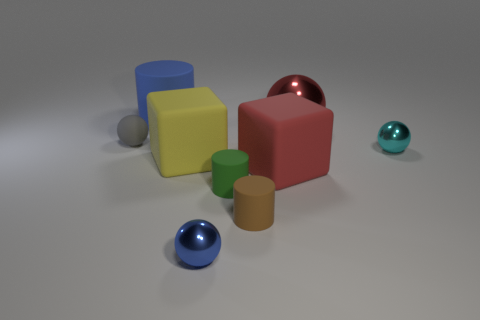What is the shape of the big red thing that is made of the same material as the small blue thing?
Give a very brief answer. Sphere. There is a rubber cylinder that is behind the small ball to the right of the red matte block; what size is it?
Ensure brevity in your answer.  Large. How many tiny things are either gray rubber cylinders or gray balls?
Offer a terse response. 1. How many other things are there of the same color as the large ball?
Your response must be concise. 1. There is a object that is on the left side of the blue rubber cylinder; is it the same size as the ball in front of the yellow matte cube?
Give a very brief answer. Yes. Are the small gray sphere and the big red object in front of the small cyan metal thing made of the same material?
Make the answer very short. Yes. Is the number of small shiny balls to the right of the brown rubber object greater than the number of large red balls that are in front of the green cylinder?
Ensure brevity in your answer.  Yes. There is a rubber cube on the left side of the tiny cylinder behind the brown rubber thing; what color is it?
Offer a very short reply. Yellow. How many blocks are either large red shiny objects or blue things?
Your response must be concise. 0. How many tiny metal things are in front of the big yellow object and behind the tiny brown thing?
Your answer should be compact. 0. 